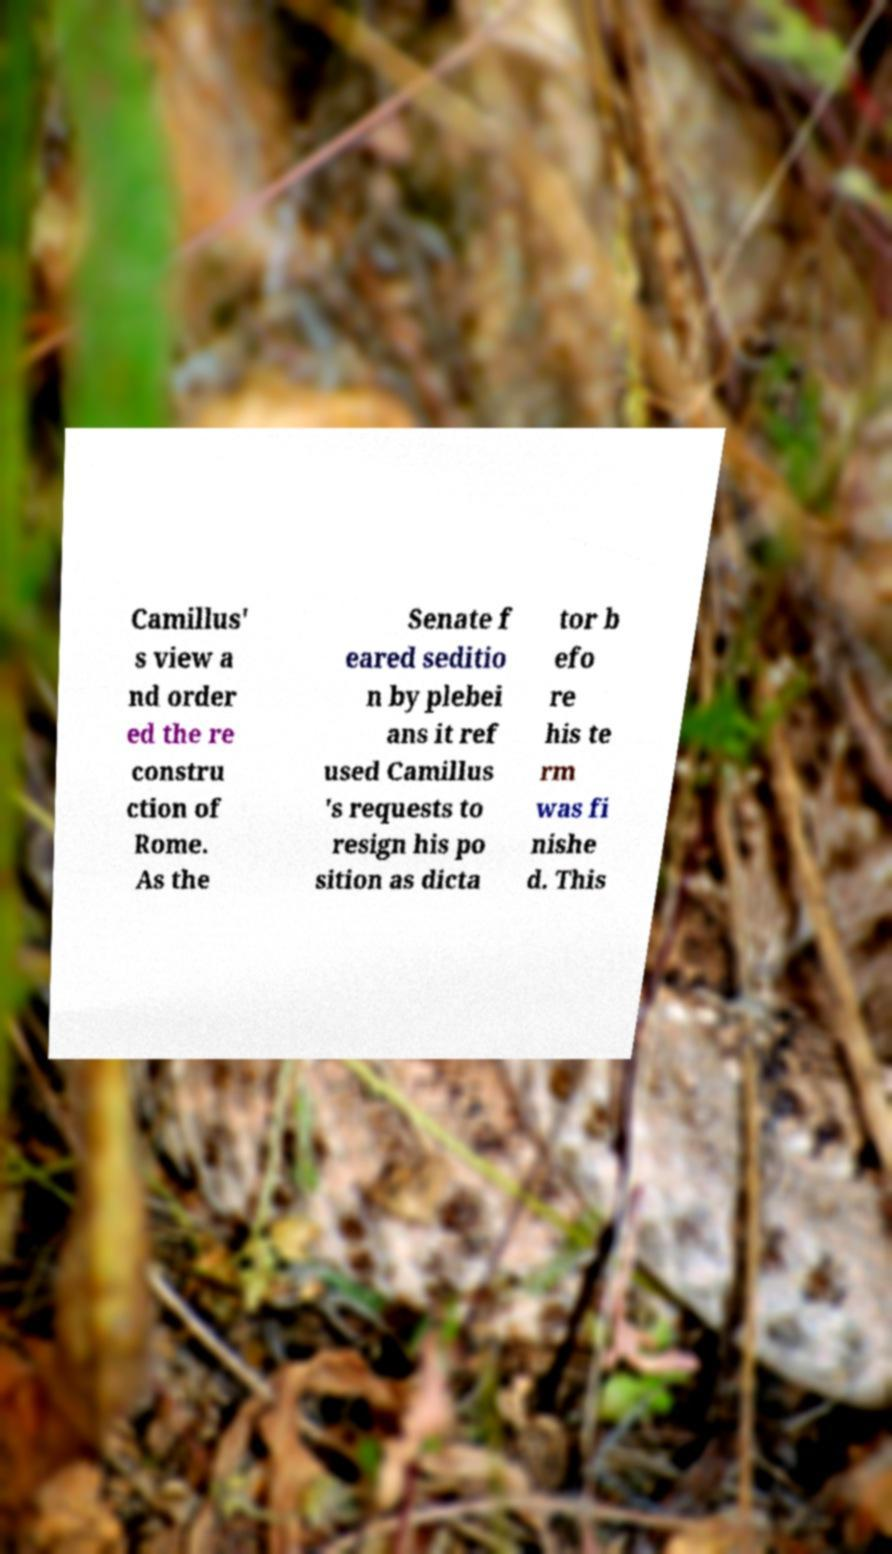What messages or text are displayed in this image? I need them in a readable, typed format. Camillus' s view a nd order ed the re constru ction of Rome. As the Senate f eared seditio n by plebei ans it ref used Camillus 's requests to resign his po sition as dicta tor b efo re his te rm was fi nishe d. This 